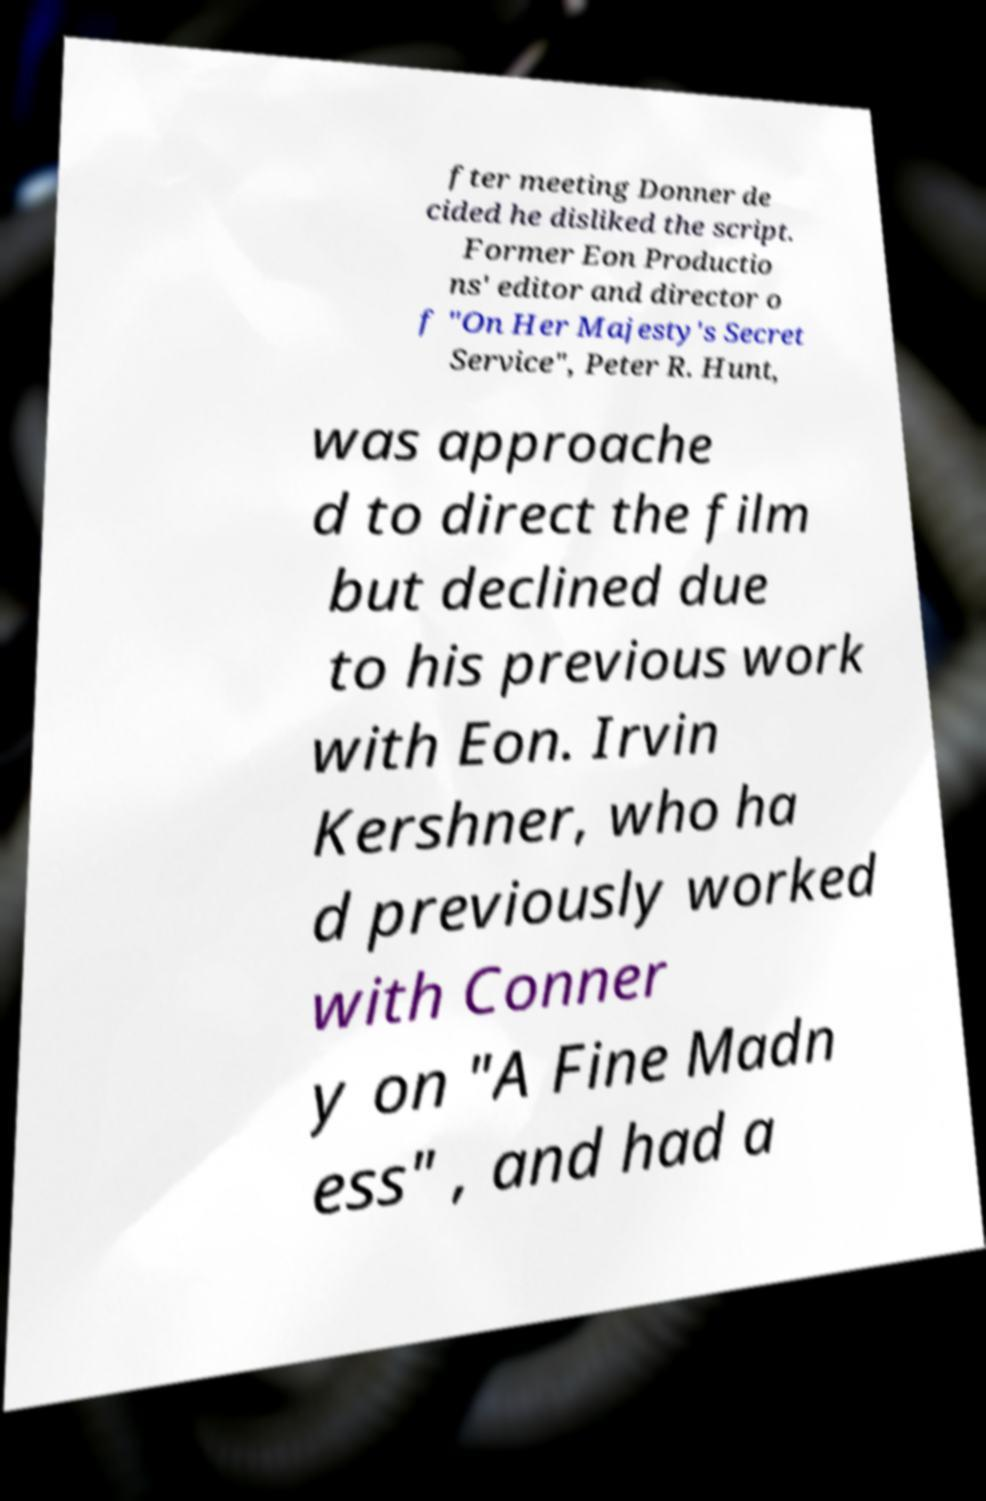Could you extract and type out the text from this image? fter meeting Donner de cided he disliked the script. Former Eon Productio ns' editor and director o f "On Her Majesty's Secret Service", Peter R. Hunt, was approache d to direct the film but declined due to his previous work with Eon. Irvin Kershner, who ha d previously worked with Conner y on "A Fine Madn ess" , and had a 